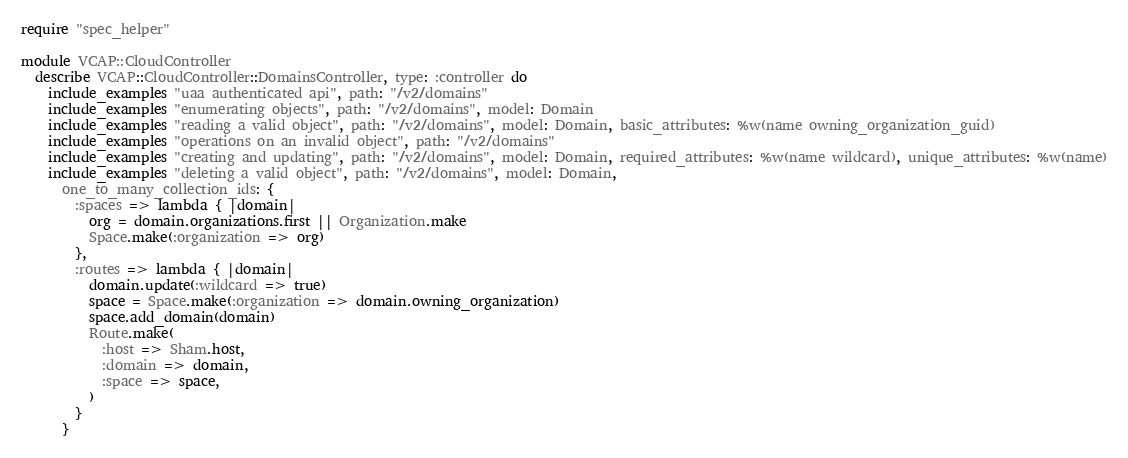<code> <loc_0><loc_0><loc_500><loc_500><_Ruby_>require "spec_helper"

module VCAP::CloudController
  describe VCAP::CloudController::DomainsController, type: :controller do
    include_examples "uaa authenticated api", path: "/v2/domains"
    include_examples "enumerating objects", path: "/v2/domains", model: Domain
    include_examples "reading a valid object", path: "/v2/domains", model: Domain, basic_attributes: %w(name owning_organization_guid)
    include_examples "operations on an invalid object", path: "/v2/domains"
    include_examples "creating and updating", path: "/v2/domains", model: Domain, required_attributes: %w(name wildcard), unique_attributes: %w(name)
    include_examples "deleting a valid object", path: "/v2/domains", model: Domain,
      one_to_many_collection_ids: {
        :spaces => lambda { |domain|
          org = domain.organizations.first || Organization.make
          Space.make(:organization => org)
        },
        :routes => lambda { |domain|
          domain.update(:wildcard => true)
          space = Space.make(:organization => domain.owning_organization)
          space.add_domain(domain)
          Route.make(
            :host => Sham.host,
            :domain => domain,
            :space => space,
          )
        }
      }
</code> 